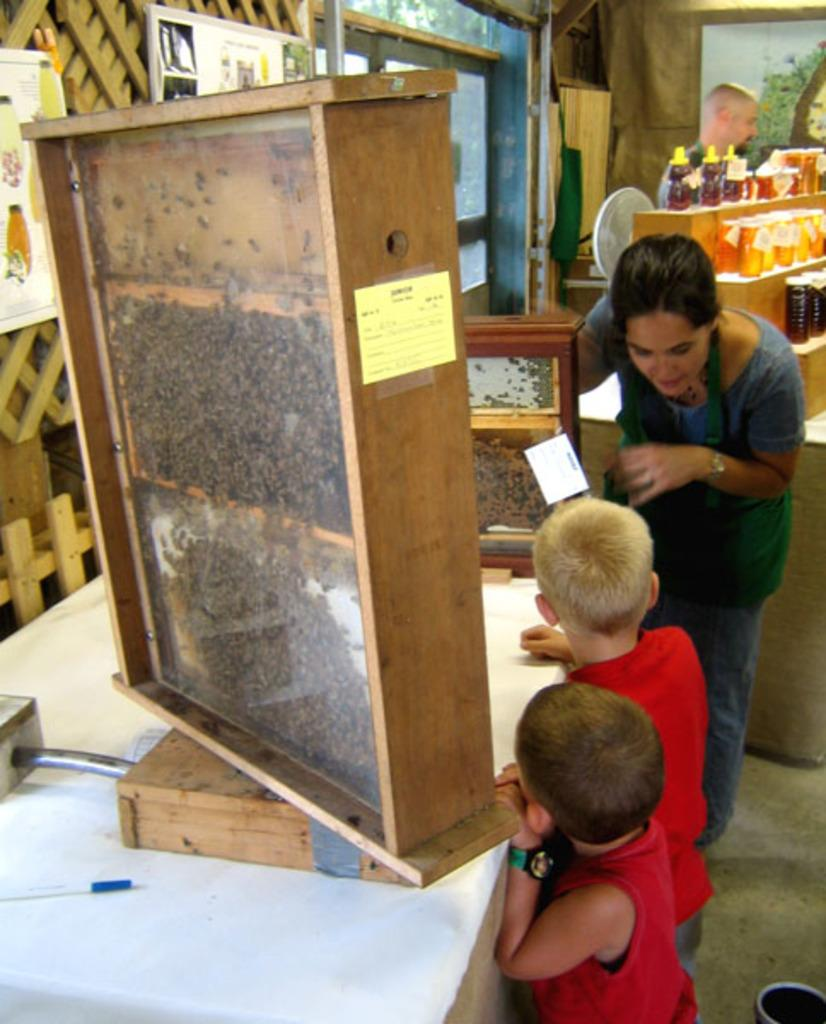How many people are present in the image? There are three people in the image. What can be seen on the table in the image? There are wooden objects on the table. What is visible in the background of the image? In the background, there are objects on a table, and there is a person standing near the wall. What type of hairstyle does the woman in the image have? There is no woman present in the image, and therefore no hairstyle can be observed. Where is the library located in the image? There is no library present in the image. 